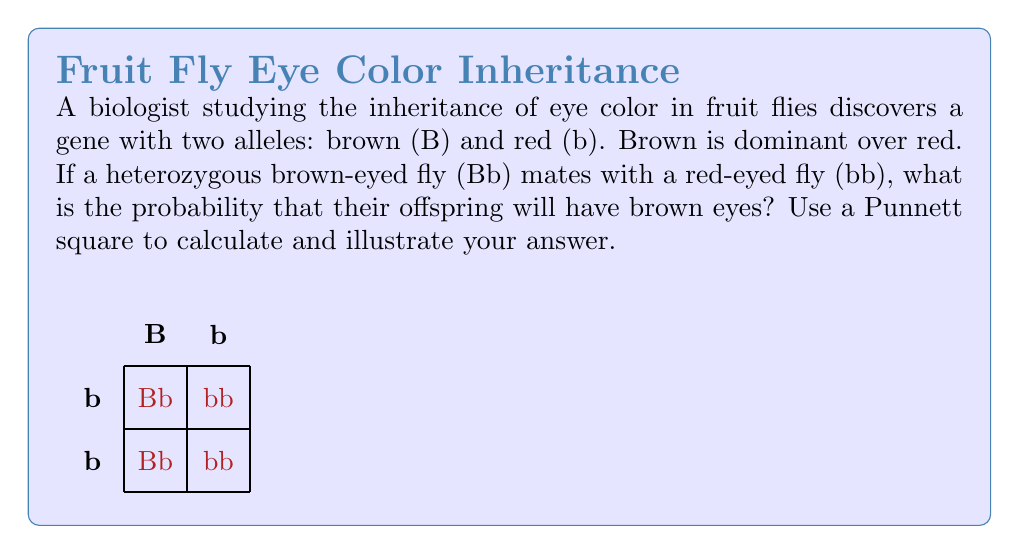Show me your answer to this math problem. To solve this problem, we'll use a Punnett square and follow these steps:

1) First, identify the genotypes of the parent flies:
   - Heterozygous brown-eyed fly: Bb
   - Red-eyed fly: bb

2) Set up the Punnett square:
   - Place the alleles of one parent (Bb) along the top
   - Place the alleles of the other parent (bb) along the left side

3) Fill in the Punnett square by combining the alleles:
   - Bb x bb produces: Bb, Bb, bb, bb

4) Count the outcomes:
   - 2 offspring have the genotype Bb (brown eyes)
   - 2 offspring have the genotype bb (red eyes)

5) Calculate the probability:
   - Total number of offspring: 4
   - Number of brown-eyed offspring: 2
   - Probability = $\frac{\text{favorable outcomes}}{\text{total outcomes}} = \frac{2}{4} = \frac{1}{2}$

6) Convert to percentage:
   $\frac{1}{2} \times 100\% = 50\%$

The Punnett square visually demonstrates that half of the offspring will inherit the dominant brown eye allele (B) from the heterozygous parent, resulting in brown eyes.
Answer: $\frac{1}{2}$ or 50% 